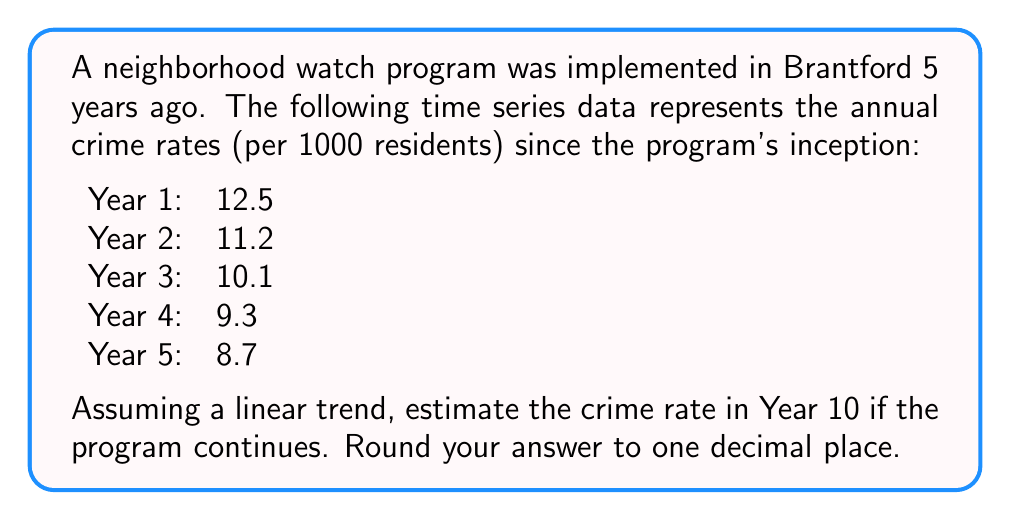Help me with this question. To estimate the crime rate in Year 10 using time series analysis with a linear trend, we'll follow these steps:

1. Calculate the average annual decrease in crime rate:
   $$ \text{Average annual decrease} = \frac{\text{Total decrease}}{\text{Number of years - 1}} $$
   $$ = \frac{12.5 - 8.7}{5 - 1} = \frac{3.8}{4} = 0.95 $$

2. Fit a linear model:
   $$ y = mx + b $$
   where $y$ is the crime rate, $x$ is the year, $m$ is the slope (average annual decrease), and $b$ is the y-intercept.

3. Calculate the y-intercept using Year 1 data:
   $$ 12.5 = -0.95(1) + b $$
   $$ b = 12.5 + 0.95 = 13.45 $$

4. Our linear model is:
   $$ y = -0.95x + 13.45 $$

5. Estimate the crime rate for Year 10 by plugging in $x = 10$:
   $$ y = -0.95(10) + 13.45 = -9.5 + 13.45 = 3.95 $$

6. Round to one decimal place: 4.0
Answer: 4.0 crimes per 1000 residents 